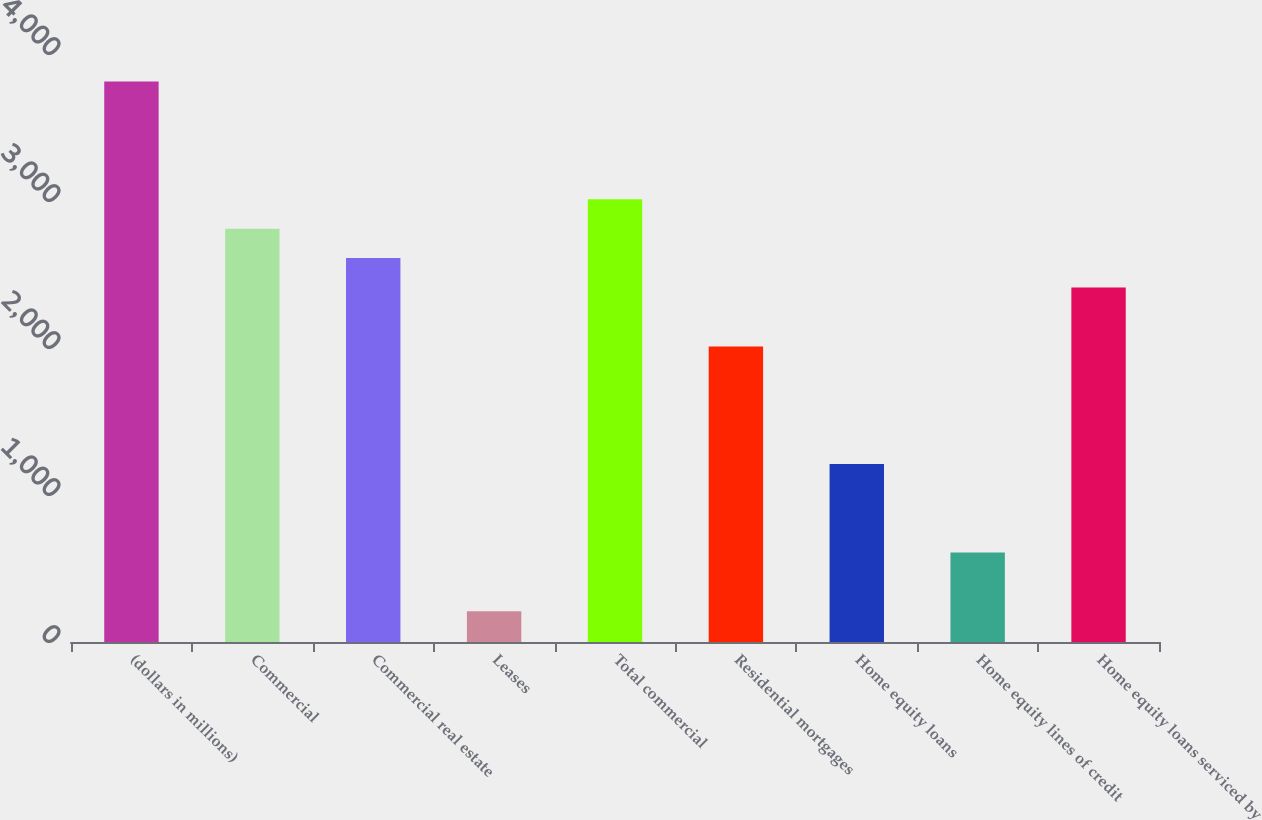Convert chart. <chart><loc_0><loc_0><loc_500><loc_500><bar_chart><fcel>(dollars in millions)<fcel>Commercial<fcel>Commercial real estate<fcel>Leases<fcel>Total commercial<fcel>Residential mortgages<fcel>Home equity loans<fcel>Home equity lines of credit<fcel>Home equity loans serviced by<nl><fcel>3812.8<fcel>2811.8<fcel>2611.6<fcel>209.2<fcel>3012<fcel>2011<fcel>1210.2<fcel>609.6<fcel>2411.4<nl></chart> 